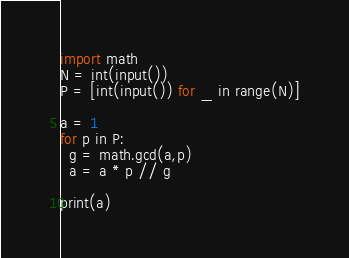Convert code to text. <code><loc_0><loc_0><loc_500><loc_500><_Python_>import math
N = int(input())
P = [int(input()) for _ in range(N)]

a = 1
for p in P:
  g = math.gcd(a,p)
  a = a * p // g

print(a)</code> 